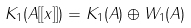Convert formula to latex. <formula><loc_0><loc_0><loc_500><loc_500>K _ { 1 } ( A [ [ x ] ] ) = K _ { 1 } ( A ) \oplus W _ { 1 } ( A )</formula> 